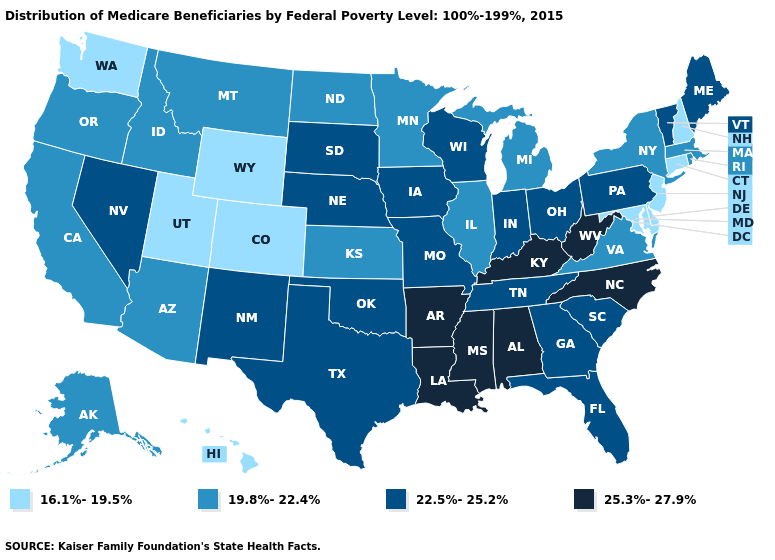Name the states that have a value in the range 25.3%-27.9%?
Be succinct. Alabama, Arkansas, Kentucky, Louisiana, Mississippi, North Carolina, West Virginia. Does Oklahoma have the highest value in the South?
Answer briefly. No. Name the states that have a value in the range 22.5%-25.2%?
Quick response, please. Florida, Georgia, Indiana, Iowa, Maine, Missouri, Nebraska, Nevada, New Mexico, Ohio, Oklahoma, Pennsylvania, South Carolina, South Dakota, Tennessee, Texas, Vermont, Wisconsin. Does South Dakota have a lower value than Massachusetts?
Keep it brief. No. Name the states that have a value in the range 25.3%-27.9%?
Quick response, please. Alabama, Arkansas, Kentucky, Louisiana, Mississippi, North Carolina, West Virginia. What is the value of South Carolina?
Give a very brief answer. 22.5%-25.2%. Does Iowa have a higher value than Louisiana?
Short answer required. No. Does Rhode Island have a lower value than New Hampshire?
Give a very brief answer. No. Among the states that border Wisconsin , does Iowa have the lowest value?
Quick response, please. No. Does Kansas have the highest value in the MidWest?
Answer briefly. No. Is the legend a continuous bar?
Answer briefly. No. Does South Carolina have a lower value than North Carolina?
Give a very brief answer. Yes. Does Indiana have the lowest value in the USA?
Quick response, please. No. Name the states that have a value in the range 16.1%-19.5%?
Quick response, please. Colorado, Connecticut, Delaware, Hawaii, Maryland, New Hampshire, New Jersey, Utah, Washington, Wyoming. What is the lowest value in the USA?
Short answer required. 16.1%-19.5%. 